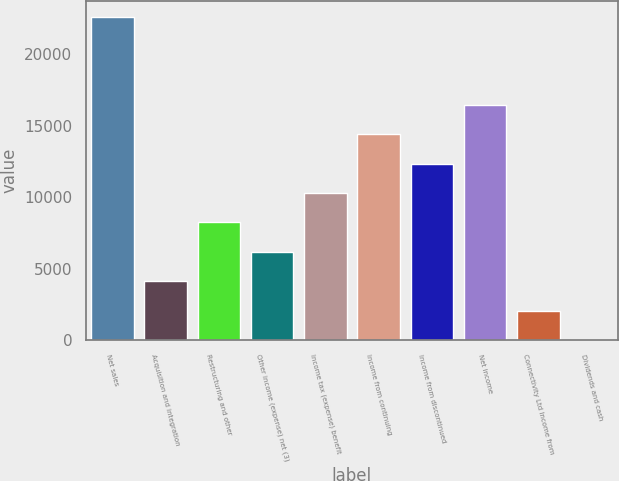<chart> <loc_0><loc_0><loc_500><loc_500><bar_chart><fcel>Net sales<fcel>Acquisition and integration<fcel>Restructuring and other<fcel>Other income (expense) net (3)<fcel>Income tax (expense) benefit<fcel>Income from continuing<fcel>Income from discontinued<fcel>Net income<fcel>Connectivity Ltd Income from<fcel>Dividends and cash<nl><fcel>22647.8<fcel>4118.8<fcel>8236.36<fcel>6177.58<fcel>10295.1<fcel>14412.7<fcel>12353.9<fcel>16471.5<fcel>2060.02<fcel>1.24<nl></chart> 